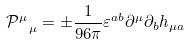<formula> <loc_0><loc_0><loc_500><loc_500>\mathcal { P } ^ { \mu } _ { \ \mu } = \pm \frac { 1 } { 9 6 \pi } \varepsilon ^ { a b } \partial ^ { \mu } \partial _ { b } h _ { \mu a }</formula> 